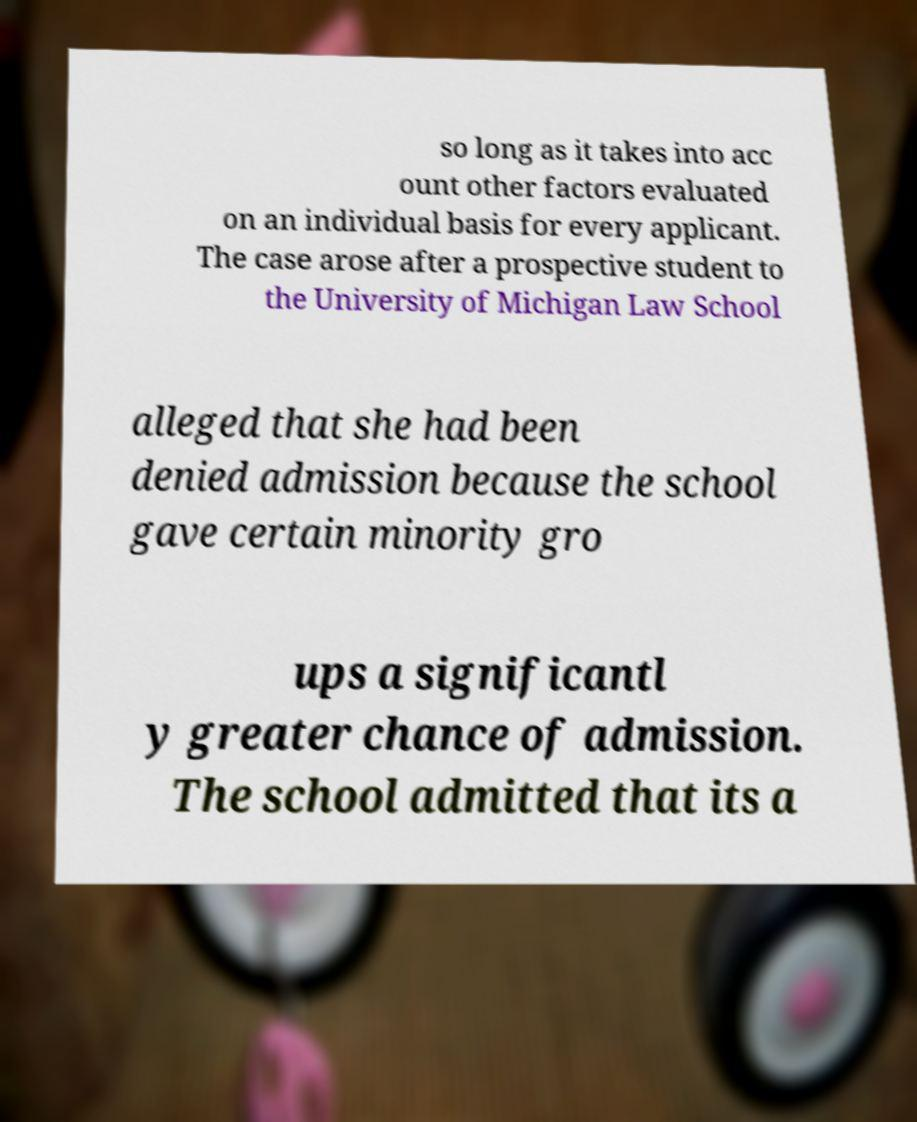Can you read and provide the text displayed in the image?This photo seems to have some interesting text. Can you extract and type it out for me? so long as it takes into acc ount other factors evaluated on an individual basis for every applicant. The case arose after a prospective student to the University of Michigan Law School alleged that she had been denied admission because the school gave certain minority gro ups a significantl y greater chance of admission. The school admitted that its a 